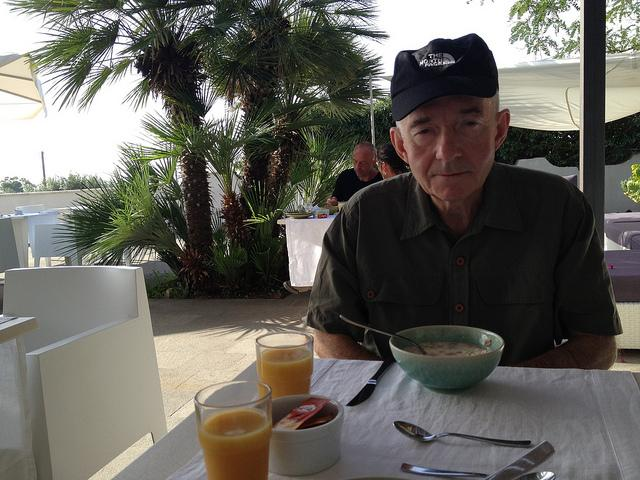What time of day does this man dine here?

Choices:
A) noon
B) night
C) morning
D) evening morning 